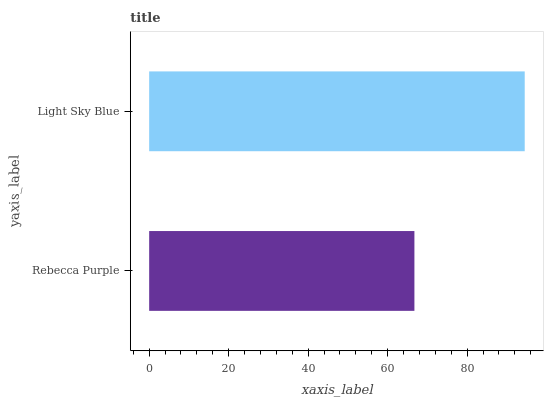Is Rebecca Purple the minimum?
Answer yes or no. Yes. Is Light Sky Blue the maximum?
Answer yes or no. Yes. Is Light Sky Blue the minimum?
Answer yes or no. No. Is Light Sky Blue greater than Rebecca Purple?
Answer yes or no. Yes. Is Rebecca Purple less than Light Sky Blue?
Answer yes or no. Yes. Is Rebecca Purple greater than Light Sky Blue?
Answer yes or no. No. Is Light Sky Blue less than Rebecca Purple?
Answer yes or no. No. Is Light Sky Blue the high median?
Answer yes or no. Yes. Is Rebecca Purple the low median?
Answer yes or no. Yes. Is Rebecca Purple the high median?
Answer yes or no. No. Is Light Sky Blue the low median?
Answer yes or no. No. 